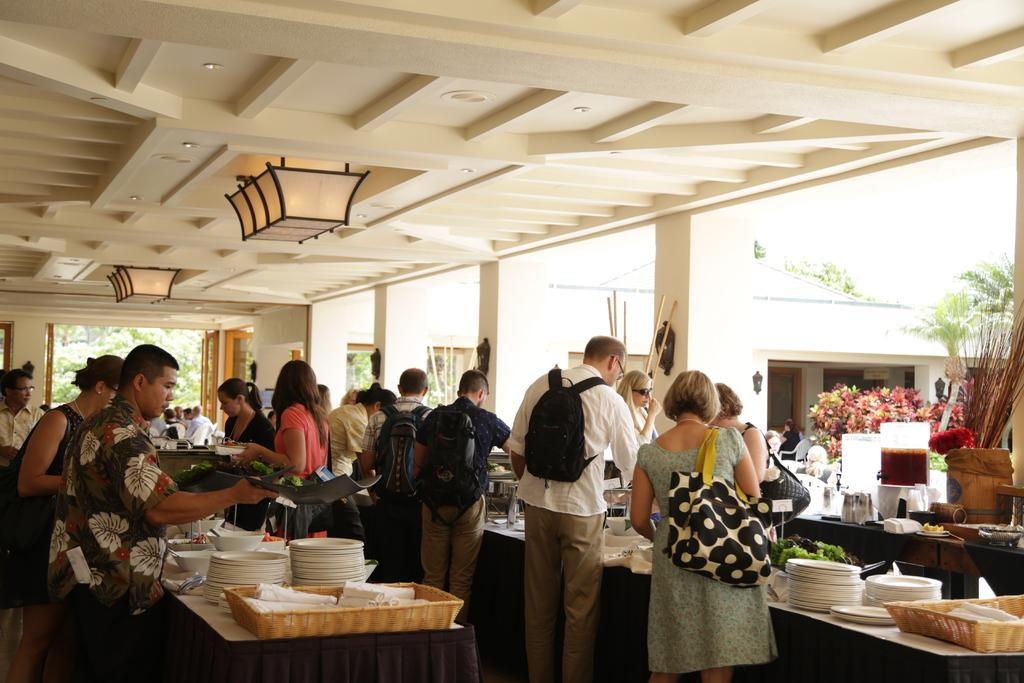What is happening in the image involving a group of people? In the image, there is a group of people standing and serving food onto plates. Can you describe the people's actions in more detail? The people are serving food onto plates, which suggests they might be working at a buffet or a food service event. What can be seen in the background of the image? There are trees visible in the image. What type of bean is being used to garnish the plates in the image? There is no bean visible in the image, as the people are serving food onto plates, but no specific ingredients are mentioned or shown. 